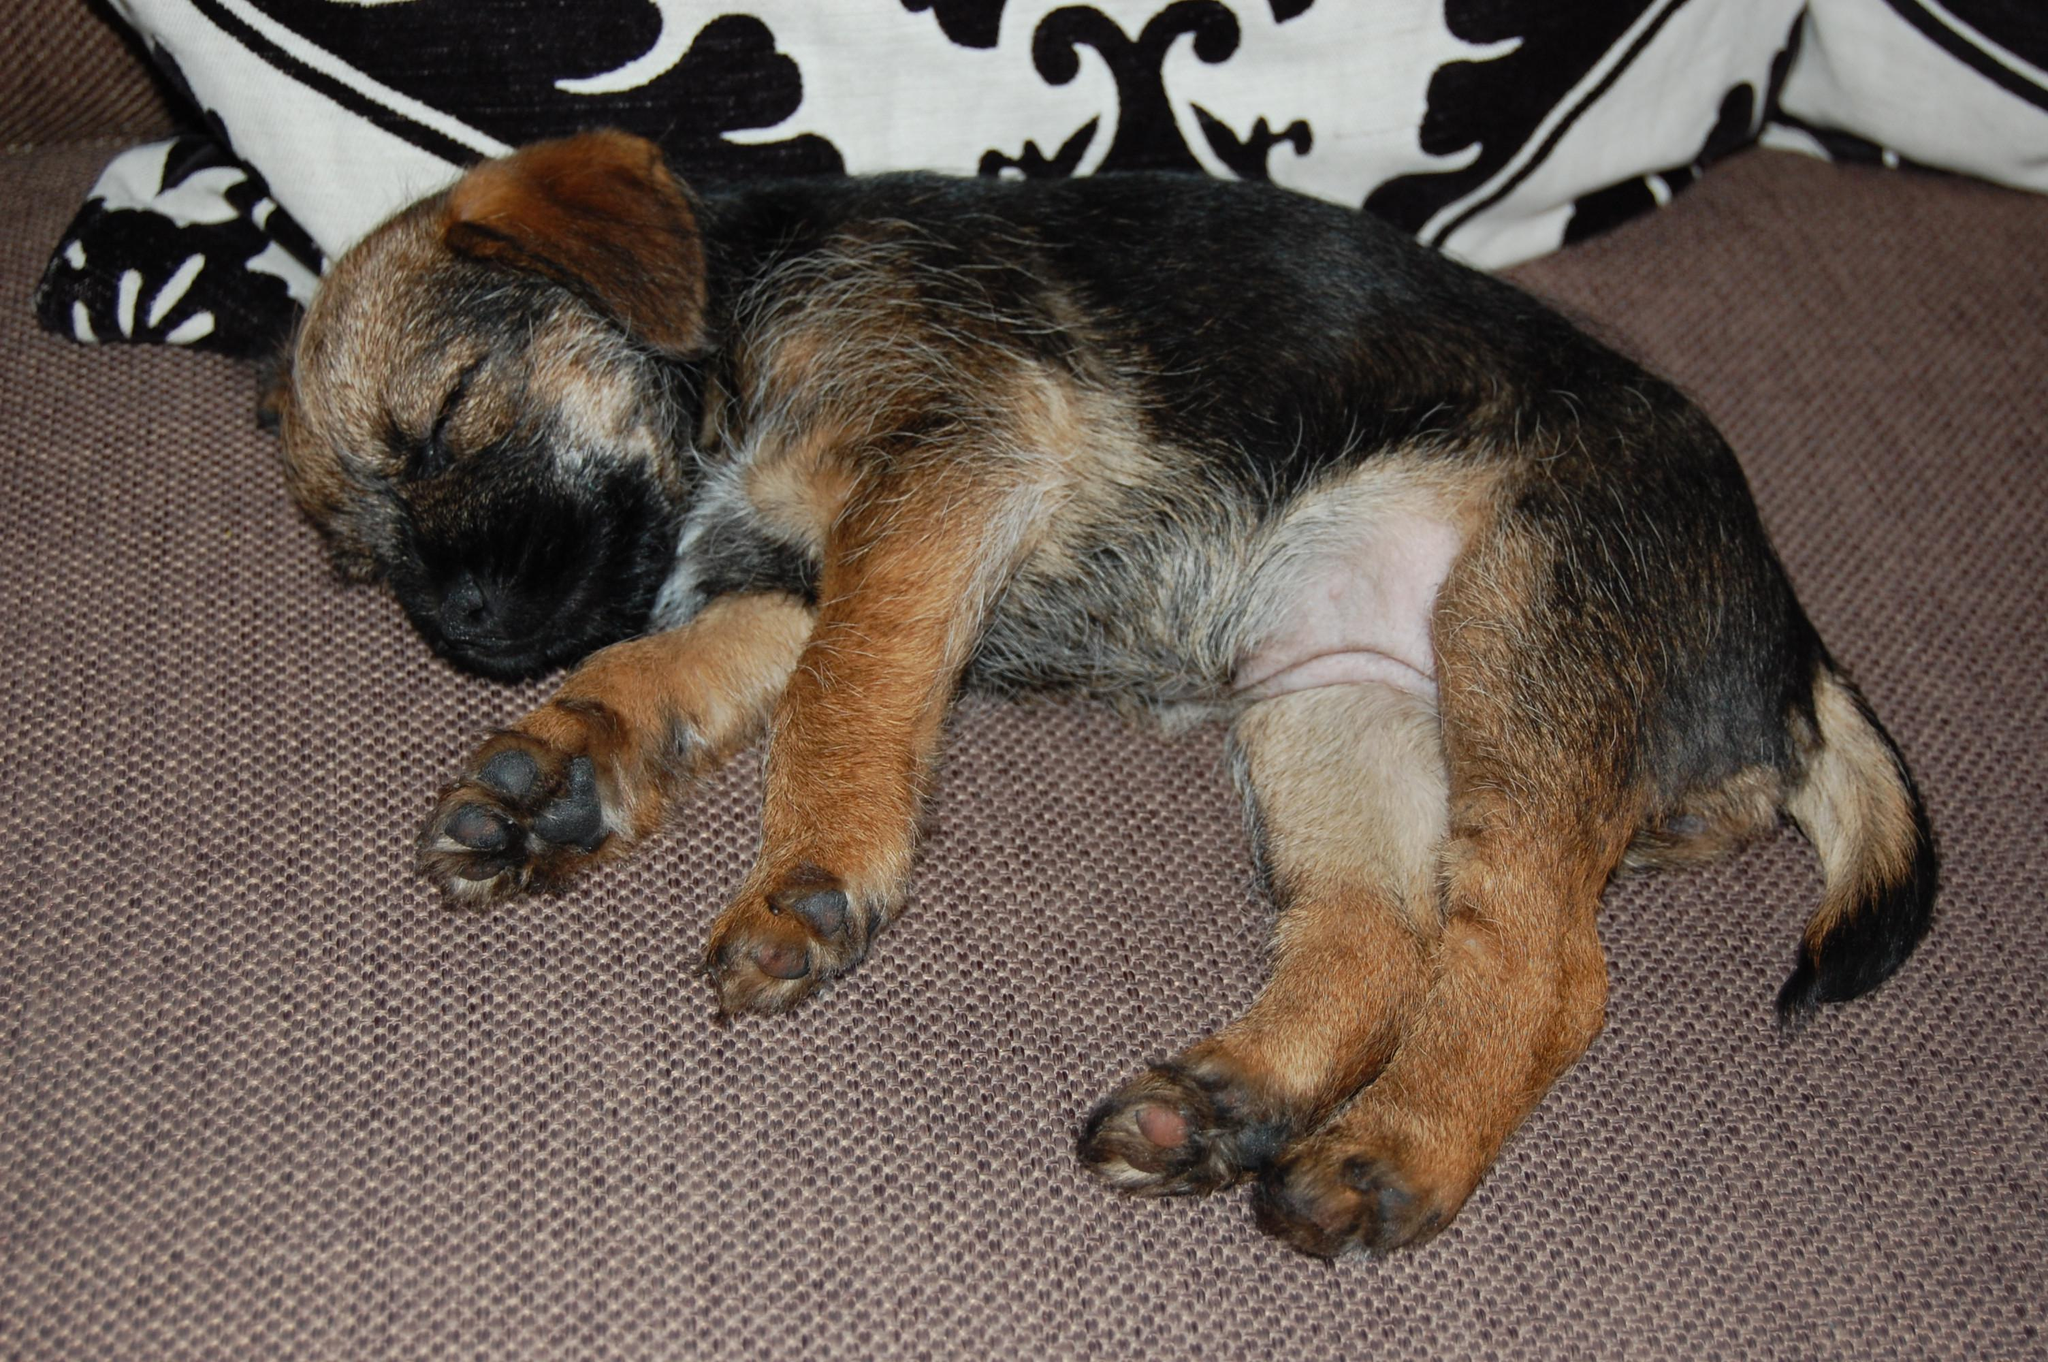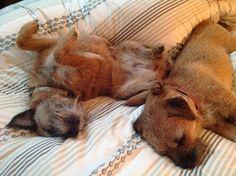The first image is the image on the left, the second image is the image on the right. Evaluate the accuracy of this statement regarding the images: "One dog is sleeping directly on a hard, wood-look floor.". Is it true? Answer yes or no. No. The first image is the image on the left, the second image is the image on the right. Given the left and right images, does the statement "A puppy is asleep on a wooden floor." hold true? Answer yes or no. No. 